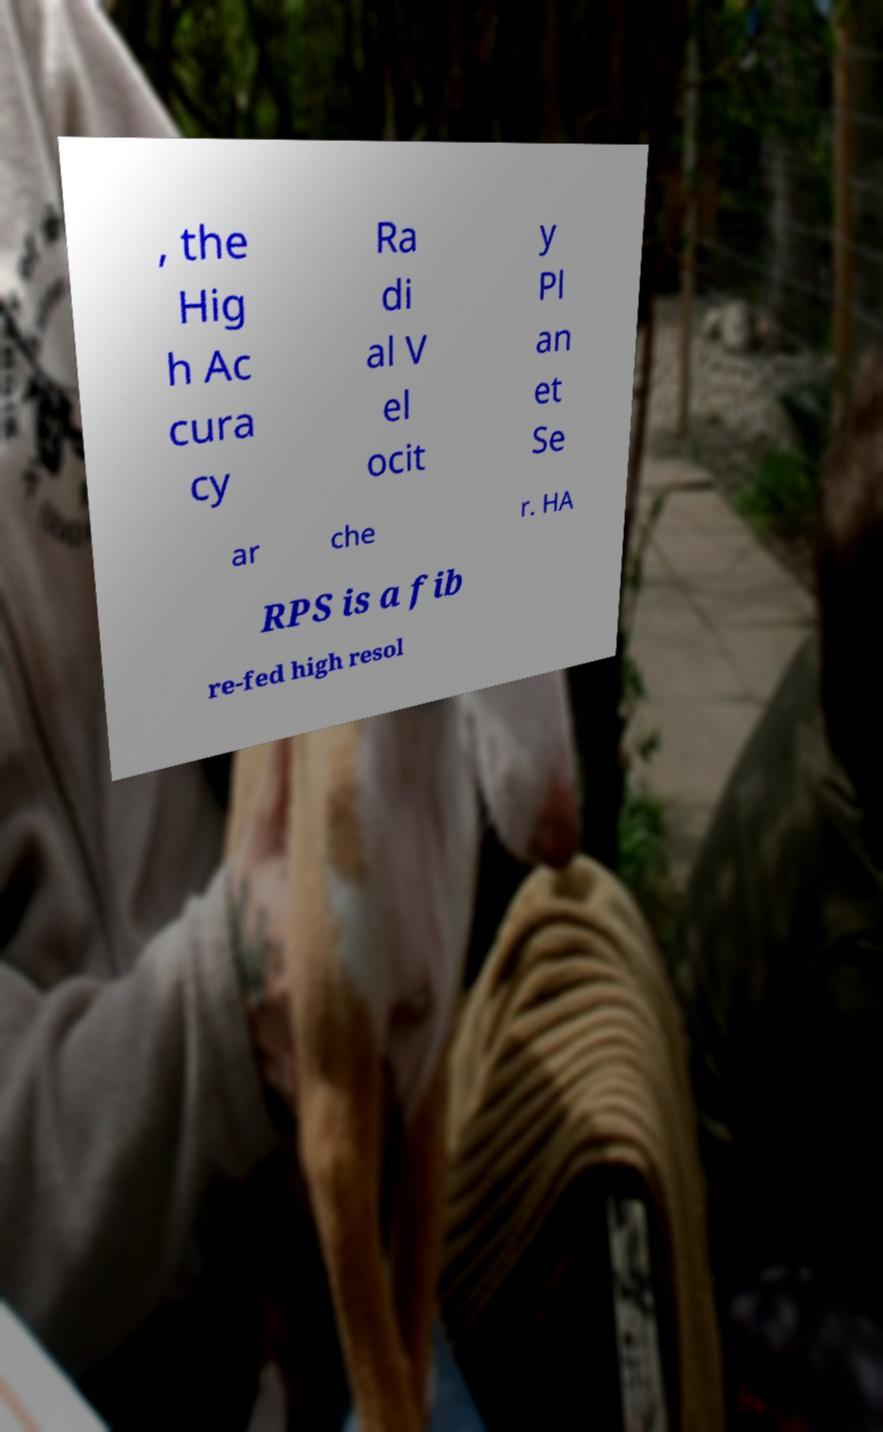What messages or text are displayed in this image? I need them in a readable, typed format. , the Hig h Ac cura cy Ra di al V el ocit y Pl an et Se ar che r. HA RPS is a fib re-fed high resol 